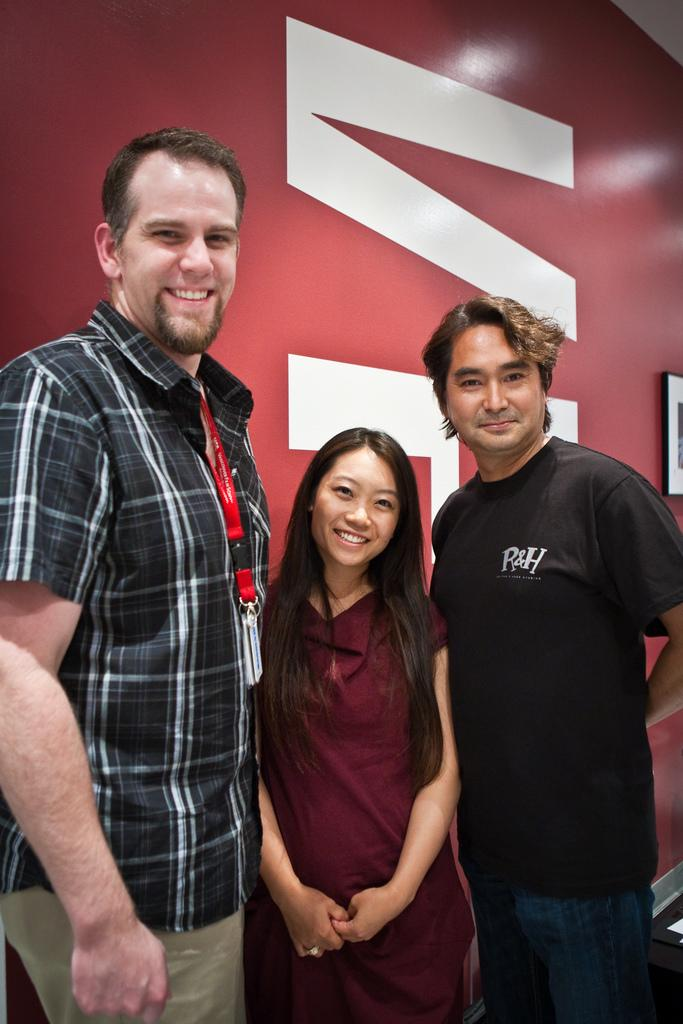How many people are present in the image? There are three people standing in the image. What can be seen in the background of the image? There is a wall with a frame in the background of the image. What type of flowers are depicted in the frame on the wall? There is no frame or flowers visible in the image; only the three people and the wall are present. 